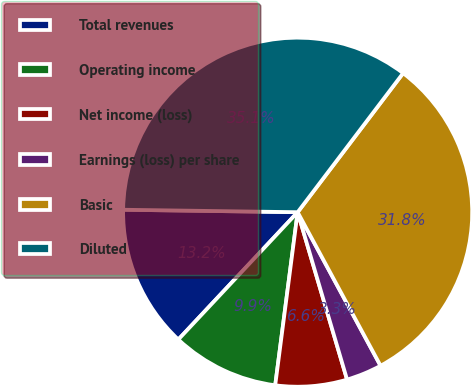Convert chart. <chart><loc_0><loc_0><loc_500><loc_500><pie_chart><fcel>Total revenues<fcel>Operating income<fcel>Net income (loss)<fcel>Earnings (loss) per share<fcel>Basic<fcel>Diluted<nl><fcel>13.24%<fcel>9.93%<fcel>6.62%<fcel>3.31%<fcel>31.79%<fcel>35.1%<nl></chart> 